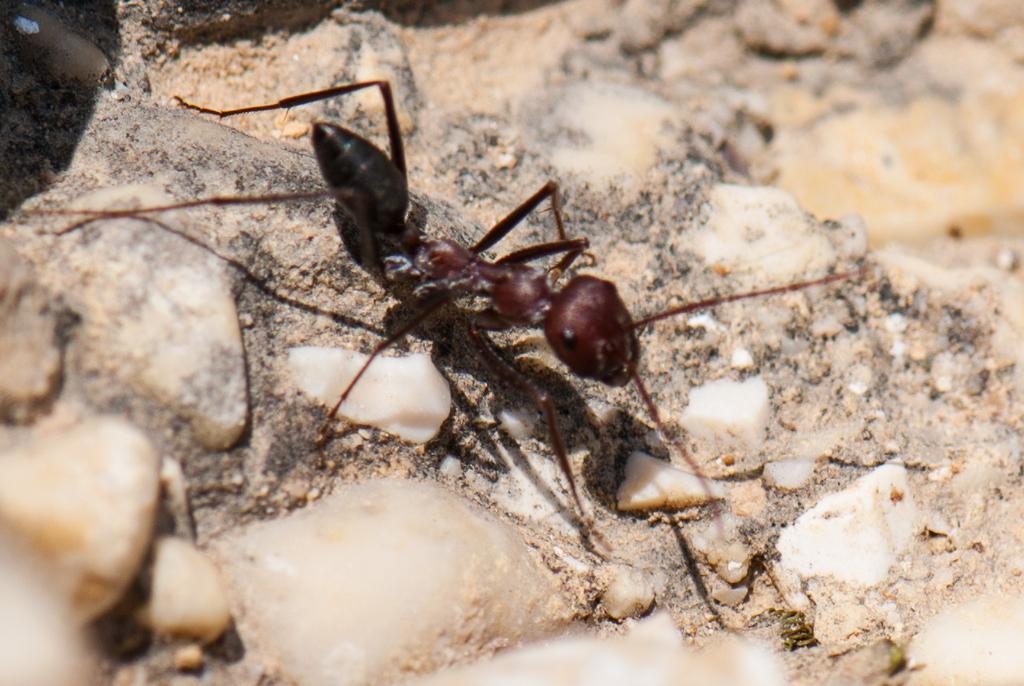Could you give a brief overview of what you see in this image? This image consists of an ant. It is in black color. 